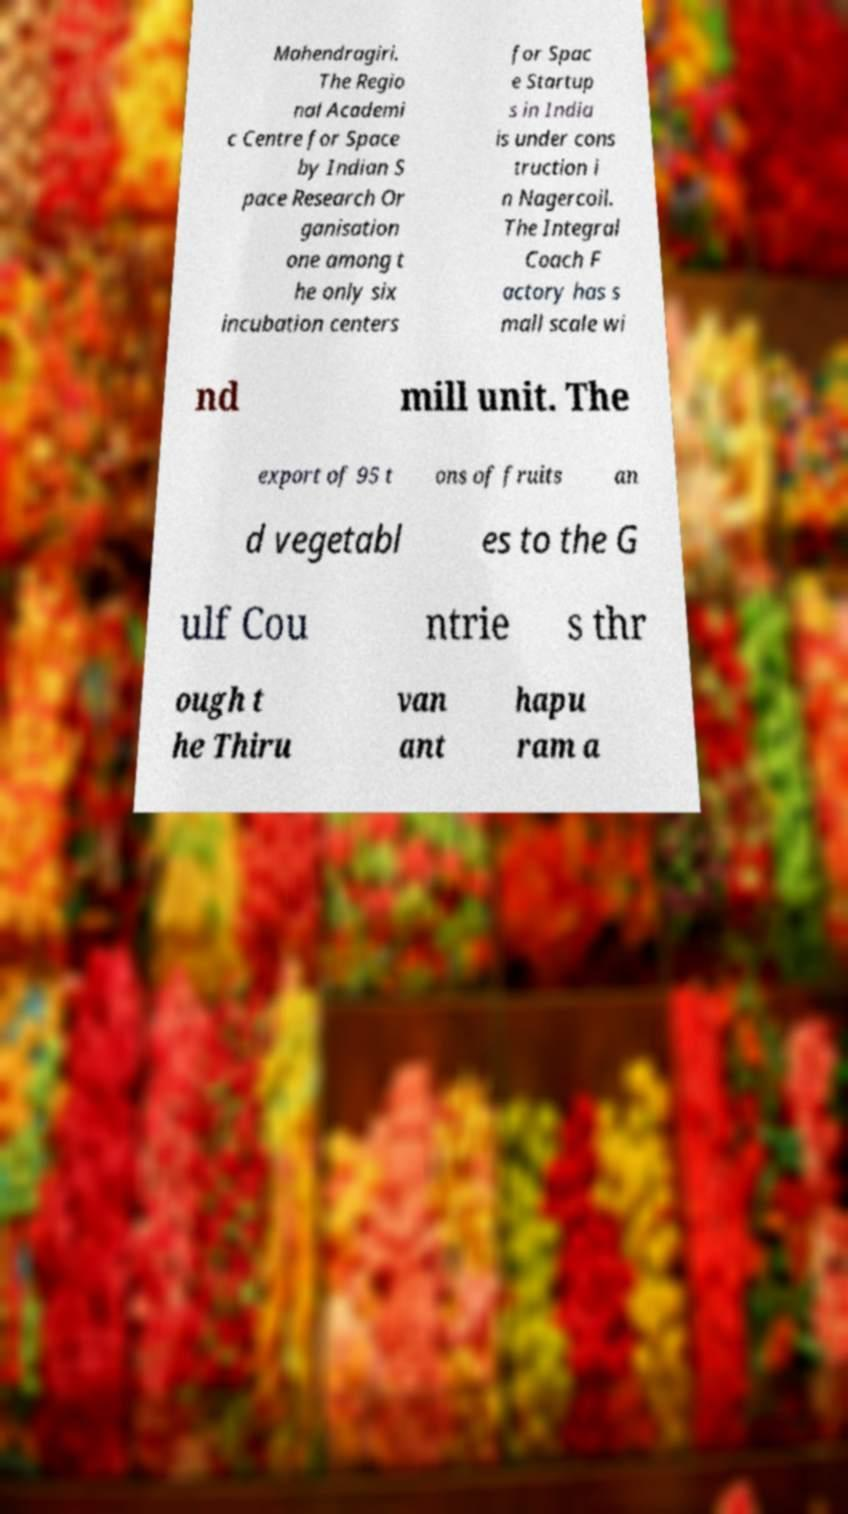For documentation purposes, I need the text within this image transcribed. Could you provide that? Mahendragiri. The Regio nal Academi c Centre for Space by Indian S pace Research Or ganisation one among t he only six incubation centers for Spac e Startup s in India is under cons truction i n Nagercoil. The Integral Coach F actory has s mall scale wi nd mill unit. The export of 95 t ons of fruits an d vegetabl es to the G ulf Cou ntrie s thr ough t he Thiru van ant hapu ram a 